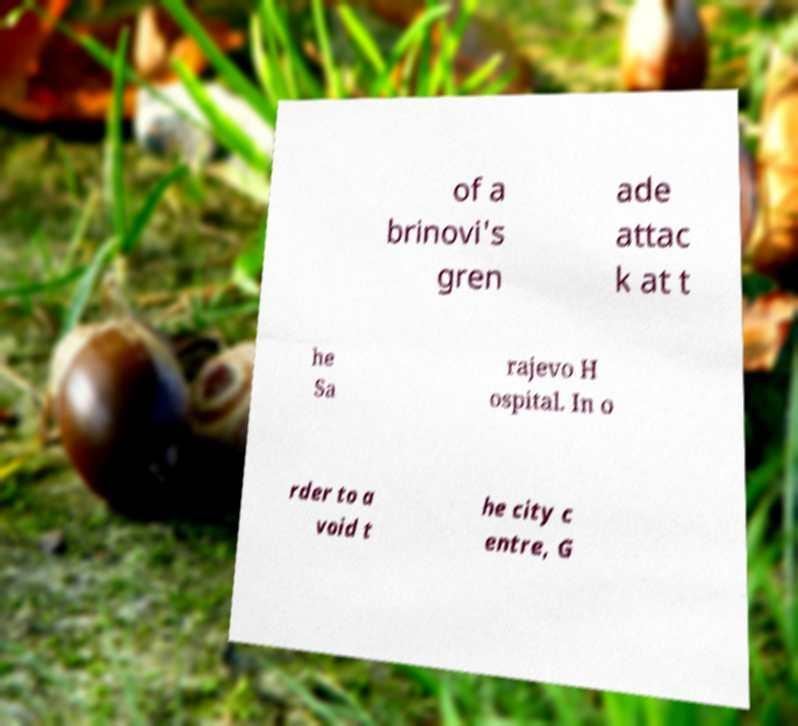Could you assist in decoding the text presented in this image and type it out clearly? of a brinovi's gren ade attac k at t he Sa rajevo H ospital. In o rder to a void t he city c entre, G 